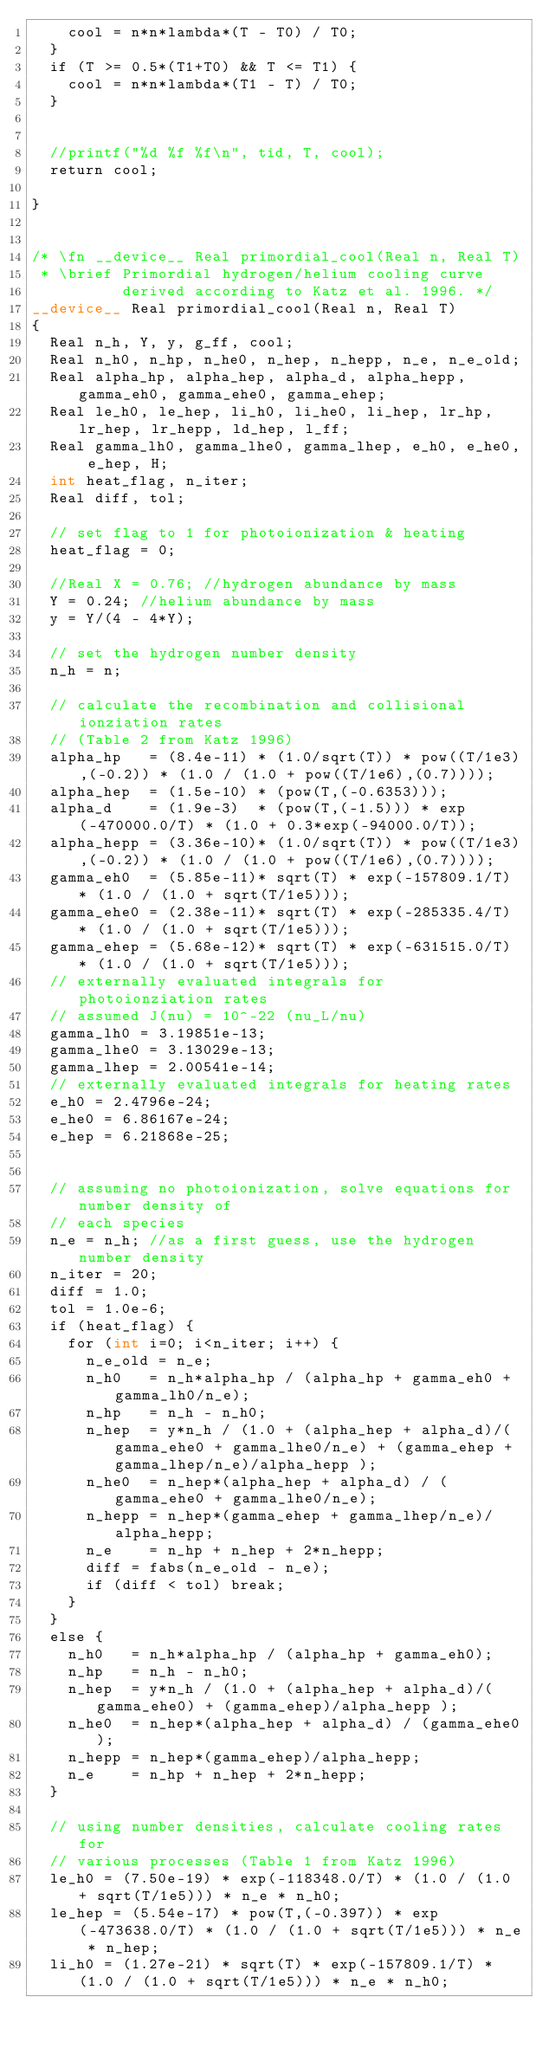Convert code to text. <code><loc_0><loc_0><loc_500><loc_500><_Cuda_>    cool = n*n*lambda*(T - T0) / T0;
  }
  if (T >= 0.5*(T1+T0) && T <= T1) {
    cool = n*n*lambda*(T1 - T) / T0;
  }
 

  //printf("%d %f %f\n", tid, T, cool);
  return cool;

}


/* \fn __device__ Real primordial_cool(Real n, Real T)
 * \brief Primordial hydrogen/helium cooling curve 
          derived according to Katz et al. 1996. */
__device__ Real primordial_cool(Real n, Real T)
{
  Real n_h, Y, y, g_ff, cool;
  Real n_h0, n_hp, n_he0, n_hep, n_hepp, n_e, n_e_old; 
  Real alpha_hp, alpha_hep, alpha_d, alpha_hepp, gamma_eh0, gamma_ehe0, gamma_ehep;
  Real le_h0, le_hep, li_h0, li_he0, li_hep, lr_hp, lr_hep, lr_hepp, ld_hep, l_ff;
  Real gamma_lh0, gamma_lhe0, gamma_lhep, e_h0, e_he0, e_hep, H;
  int heat_flag, n_iter;
  Real diff, tol;

  // set flag to 1 for photoionization & heating
  heat_flag = 0;

  //Real X = 0.76; //hydrogen abundance by mass
  Y = 0.24; //helium abundance by mass
  y = Y/(4 - 4*Y);  

  // set the hydrogen number density 
  n_h = n; 

  // calculate the recombination and collisional ionziation rates
  // (Table 2 from Katz 1996)
  alpha_hp   = (8.4e-11) * (1.0/sqrt(T)) * pow((T/1e3),(-0.2)) * (1.0 / (1.0 + pow((T/1e6),(0.7))));
  alpha_hep  = (1.5e-10) * (pow(T,(-0.6353)));
  alpha_d    = (1.9e-3)  * (pow(T,(-1.5))) * exp(-470000.0/T) * (1.0 + 0.3*exp(-94000.0/T));
  alpha_hepp = (3.36e-10)* (1.0/sqrt(T)) * pow((T/1e3),(-0.2)) * (1.0 / (1.0 + pow((T/1e6),(0.7))));
  gamma_eh0  = (5.85e-11)* sqrt(T) * exp(-157809.1/T) * (1.0 / (1.0 + sqrt(T/1e5)));
  gamma_ehe0 = (2.38e-11)* sqrt(T) * exp(-285335.4/T) * (1.0 / (1.0 + sqrt(T/1e5)));
  gamma_ehep = (5.68e-12)* sqrt(T) * exp(-631515.0/T) * (1.0 / (1.0 + sqrt(T/1e5)));
  // externally evaluated integrals for photoionziation rates
  // assumed J(nu) = 10^-22 (nu_L/nu)
  gamma_lh0 = 3.19851e-13;
  gamma_lhe0 = 3.13029e-13;
  gamma_lhep = 2.00541e-14; 
  // externally evaluated integrals for heating rates
  e_h0 = 2.4796e-24;
  e_he0 = 6.86167e-24;
  e_hep = 6.21868e-25; 
  

  // assuming no photoionization, solve equations for number density of
  // each species
  n_e = n_h; //as a first guess, use the hydrogen number density
  n_iter = 20;
  diff = 1.0;
  tol = 1.0e-6;
  if (heat_flag) { 
    for (int i=0; i<n_iter; i++) {
      n_e_old = n_e;
      n_h0   = n_h*alpha_hp / (alpha_hp + gamma_eh0 + gamma_lh0/n_e);
      n_hp   = n_h - n_h0;
      n_hep  = y*n_h / (1.0 + (alpha_hep + alpha_d)/(gamma_ehe0 + gamma_lhe0/n_e) + (gamma_ehep + gamma_lhep/n_e)/alpha_hepp );
      n_he0  = n_hep*(alpha_hep + alpha_d) / (gamma_ehe0 + gamma_lhe0/n_e);
      n_hepp = n_hep*(gamma_ehep + gamma_lhep/n_e)/alpha_hepp;
      n_e    = n_hp + n_hep + 2*n_hepp;
      diff = fabs(n_e_old - n_e);
      if (diff < tol) break;
    }
  }  
  else {
    n_h0   = n_h*alpha_hp / (alpha_hp + gamma_eh0);
    n_hp   = n_h - n_h0;
    n_hep  = y*n_h / (1.0 + (alpha_hep + alpha_d)/(gamma_ehe0) + (gamma_ehep)/alpha_hepp );
    n_he0  = n_hep*(alpha_hep + alpha_d) / (gamma_ehe0);
    n_hepp = n_hep*(gamma_ehep)/alpha_hepp;
    n_e    = n_hp + n_hep + 2*n_hepp;
  }

  // using number densities, calculate cooling rates for
  // various processes (Table 1 from Katz 1996)
  le_h0 = (7.50e-19) * exp(-118348.0/T) * (1.0 / (1.0 + sqrt(T/1e5))) * n_e * n_h0;
  le_hep = (5.54e-17) * pow(T,(-0.397)) * exp(-473638.0/T) * (1.0 / (1.0 + sqrt(T/1e5))) * n_e * n_hep;
  li_h0 = (1.27e-21) * sqrt(T) * exp(-157809.1/T) * (1.0 / (1.0 + sqrt(T/1e5))) * n_e * n_h0;</code> 